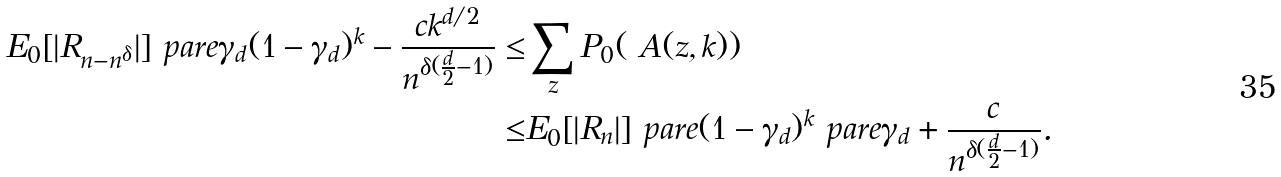Convert formula to latex. <formula><loc_0><loc_0><loc_500><loc_500>E _ { 0 } [ | R _ { n - n ^ { \delta } } | ] \ p a r e { \gamma _ { d } ( 1 - \gamma _ { d } ) ^ { k } - \frac { c k ^ { d / 2 } } { n ^ { \delta ( \frac { d } { 2 } - 1 ) } } } \leq & \sum _ { z } P _ { 0 } ( \ A ( z , k ) ) \\ \leq & E _ { 0 } [ | R _ { n } | ] \ p a r e { ( 1 - \gamma _ { d } ) ^ { k } \ p a r e { \gamma _ { d } + \frac { c } { n ^ { \delta ( \frac { d } { 2 } - 1 ) } } } } .</formula> 